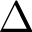Convert formula to latex. <formula><loc_0><loc_0><loc_500><loc_500>\Delta</formula> 